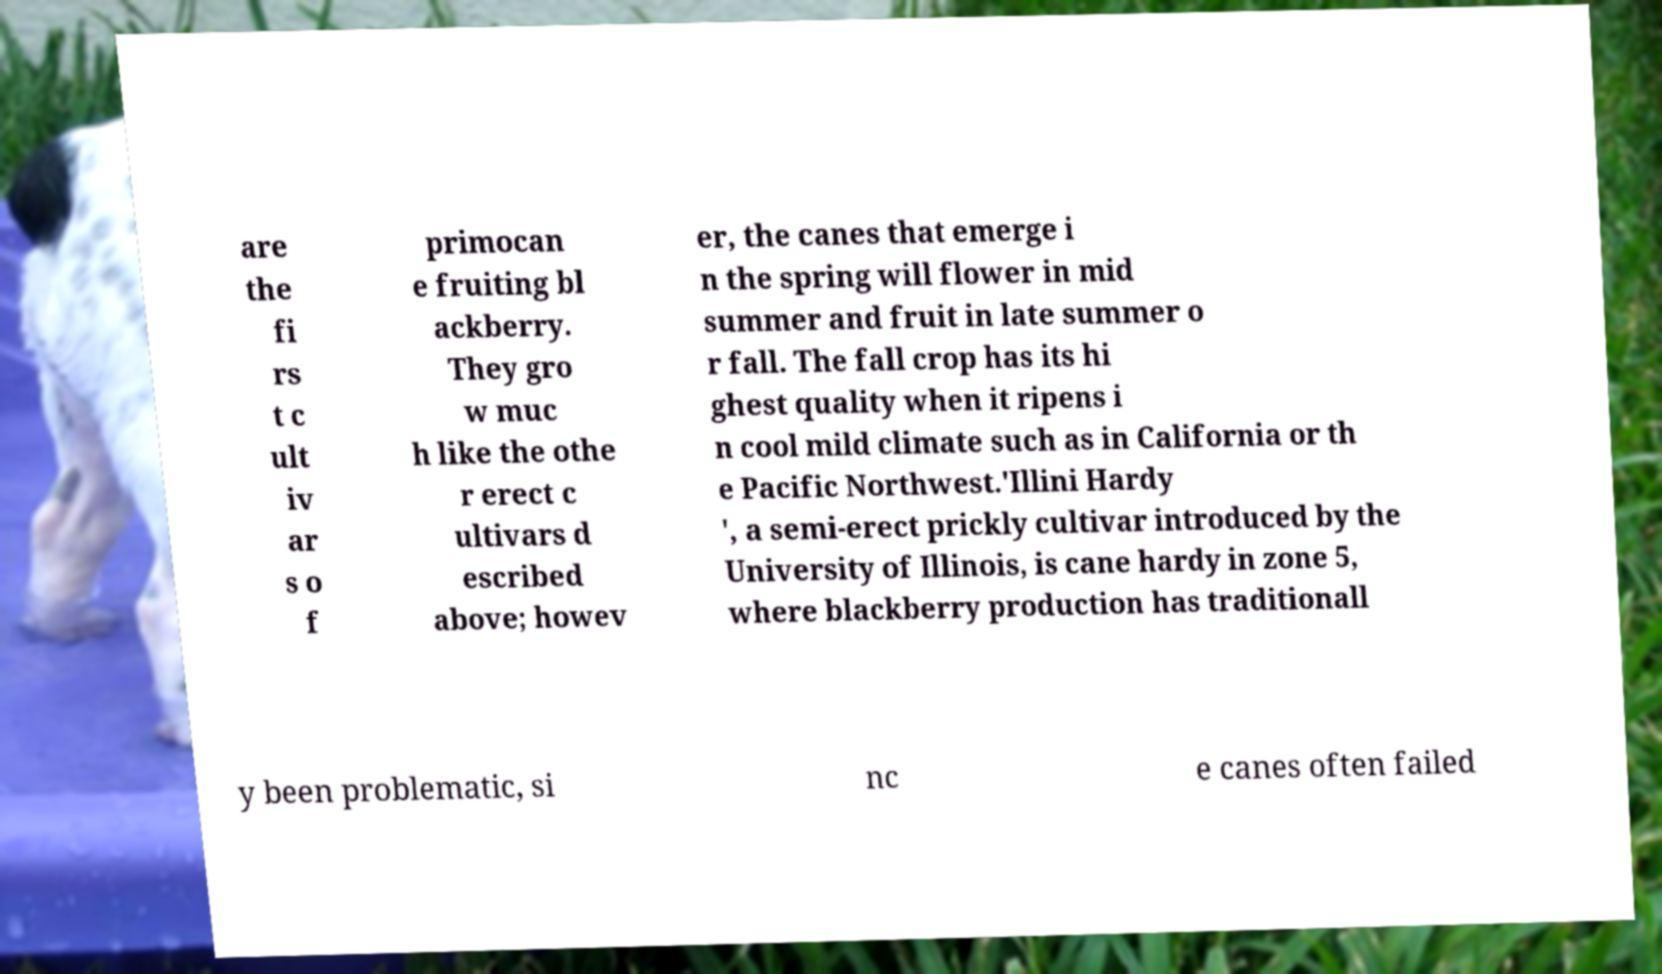Can you accurately transcribe the text from the provided image for me? are the fi rs t c ult iv ar s o f primocan e fruiting bl ackberry. They gro w muc h like the othe r erect c ultivars d escribed above; howev er, the canes that emerge i n the spring will flower in mid summer and fruit in late summer o r fall. The fall crop has its hi ghest quality when it ripens i n cool mild climate such as in California or th e Pacific Northwest.'Illini Hardy ', a semi-erect prickly cultivar introduced by the University of Illinois, is cane hardy in zone 5, where blackberry production has traditionall y been problematic, si nc e canes often failed 